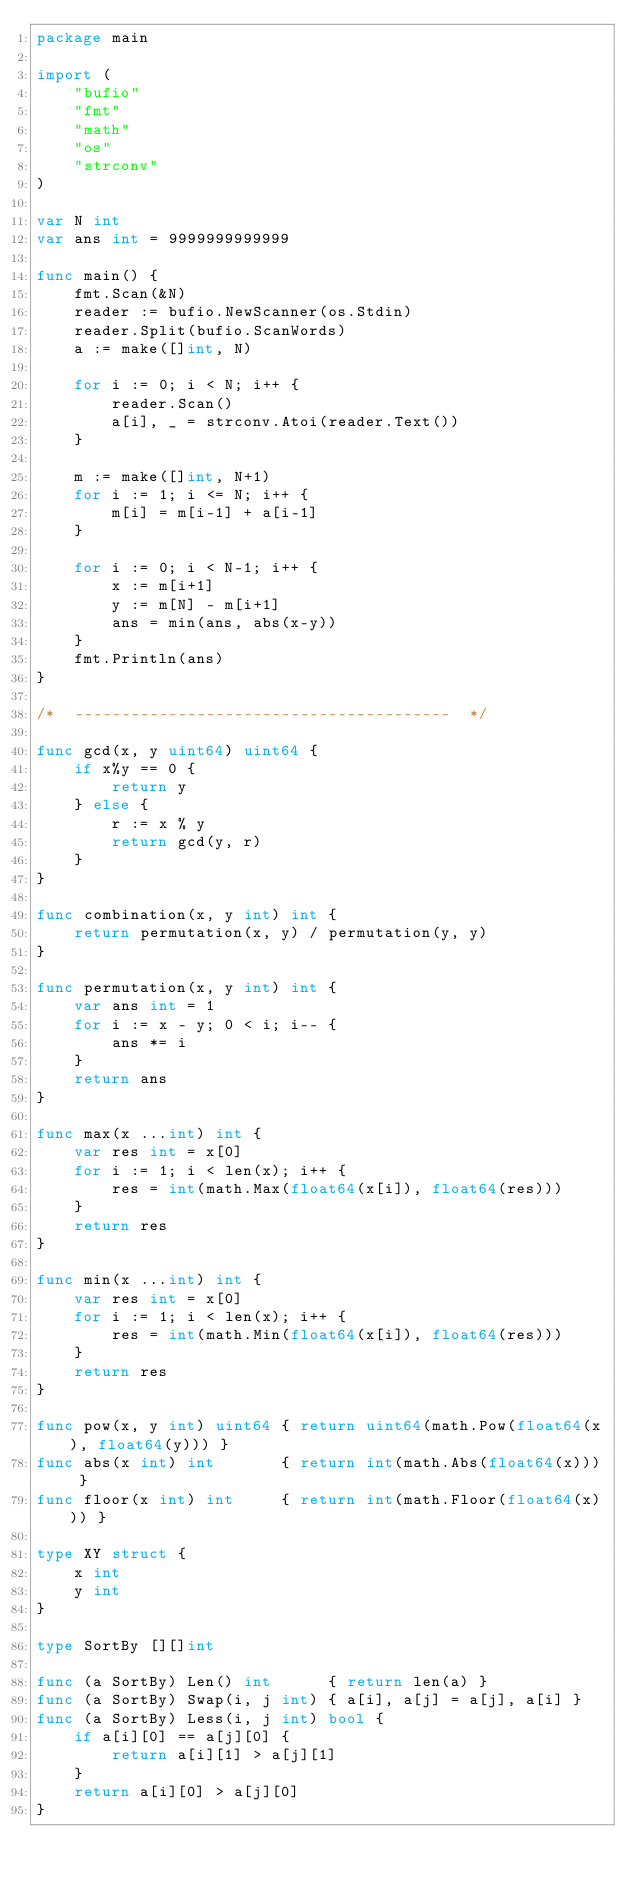<code> <loc_0><loc_0><loc_500><loc_500><_Go_>package main

import (
	"bufio"
	"fmt"
	"math"
	"os"
	"strconv"
)

var N int
var ans int = 9999999999999

func main() {
	fmt.Scan(&N)
	reader := bufio.NewScanner(os.Stdin)
	reader.Split(bufio.ScanWords)
	a := make([]int, N)

	for i := 0; i < N; i++ {
		reader.Scan()
		a[i], _ = strconv.Atoi(reader.Text())
	}

	m := make([]int, N+1)
	for i := 1; i <= N; i++ {
		m[i] = m[i-1] + a[i-1]
	}

	for i := 0; i < N-1; i++ {
		x := m[i+1]
		y := m[N] - m[i+1]
		ans = min(ans, abs(x-y))
	}
	fmt.Println(ans)
}

/*  ----------------------------------------  */

func gcd(x, y uint64) uint64 {
	if x%y == 0 {
		return y
	} else {
		r := x % y
		return gcd(y, r)
	}
}

func combination(x, y int) int {
	return permutation(x, y) / permutation(y, y)
}

func permutation(x, y int) int {
	var ans int = 1
	for i := x - y; 0 < i; i-- {
		ans *= i
	}
	return ans
}

func max(x ...int) int {
	var res int = x[0]
	for i := 1; i < len(x); i++ {
		res = int(math.Max(float64(x[i]), float64(res)))
	}
	return res
}

func min(x ...int) int {
	var res int = x[0]
	for i := 1; i < len(x); i++ {
		res = int(math.Min(float64(x[i]), float64(res)))
	}
	return res
}

func pow(x, y int) uint64 { return uint64(math.Pow(float64(x), float64(y))) }
func abs(x int) int       { return int(math.Abs(float64(x))) }
func floor(x int) int     { return int(math.Floor(float64(x))) }

type XY struct {
	x int
	y int
}

type SortBy [][]int

func (a SortBy) Len() int      { return len(a) }
func (a SortBy) Swap(i, j int) { a[i], a[j] = a[j], a[i] }
func (a SortBy) Less(i, j int) bool {
	if a[i][0] == a[j][0] {
		return a[i][1] > a[j][1]
	}
	return a[i][0] > a[j][0]
}
</code> 